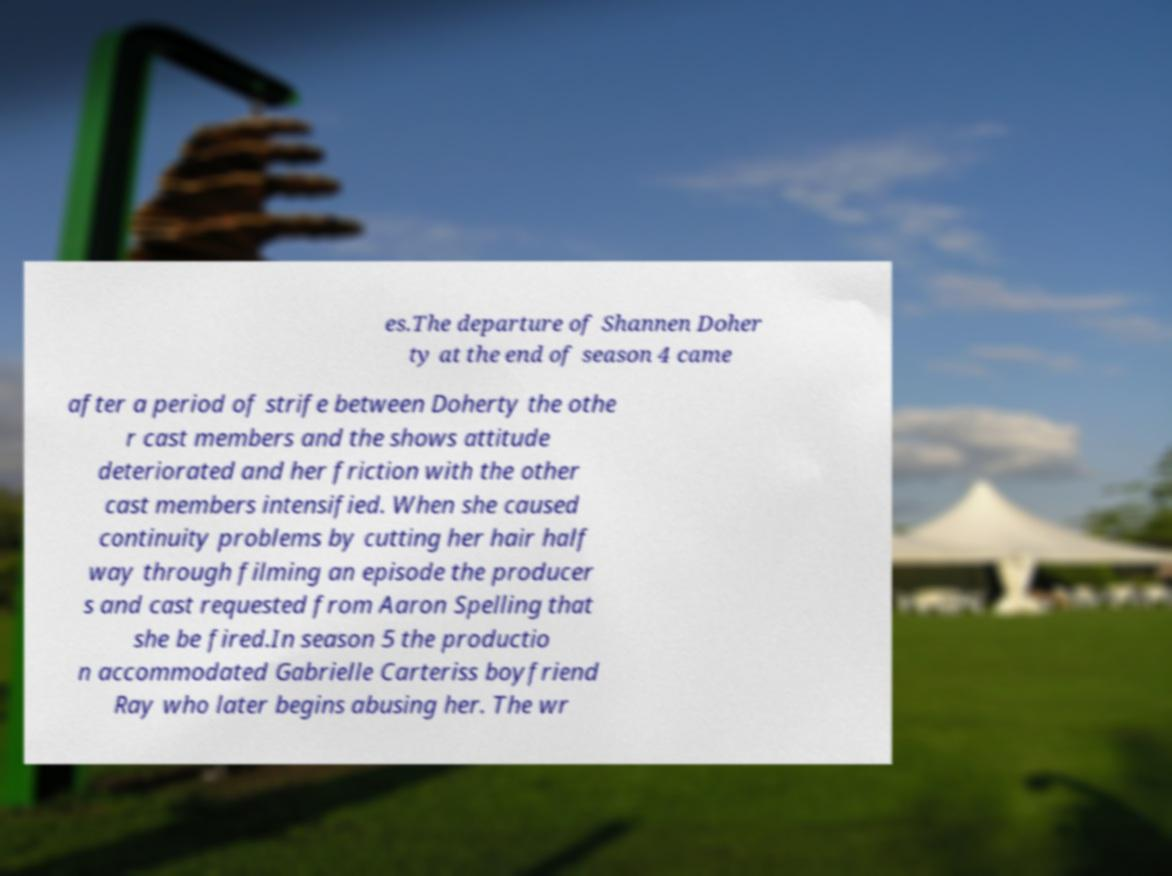Could you extract and type out the text from this image? es.The departure of Shannen Doher ty at the end of season 4 came after a period of strife between Doherty the othe r cast members and the shows attitude deteriorated and her friction with the other cast members intensified. When she caused continuity problems by cutting her hair half way through filming an episode the producer s and cast requested from Aaron Spelling that she be fired.In season 5 the productio n accommodated Gabrielle Carteriss boyfriend Ray who later begins abusing her. The wr 